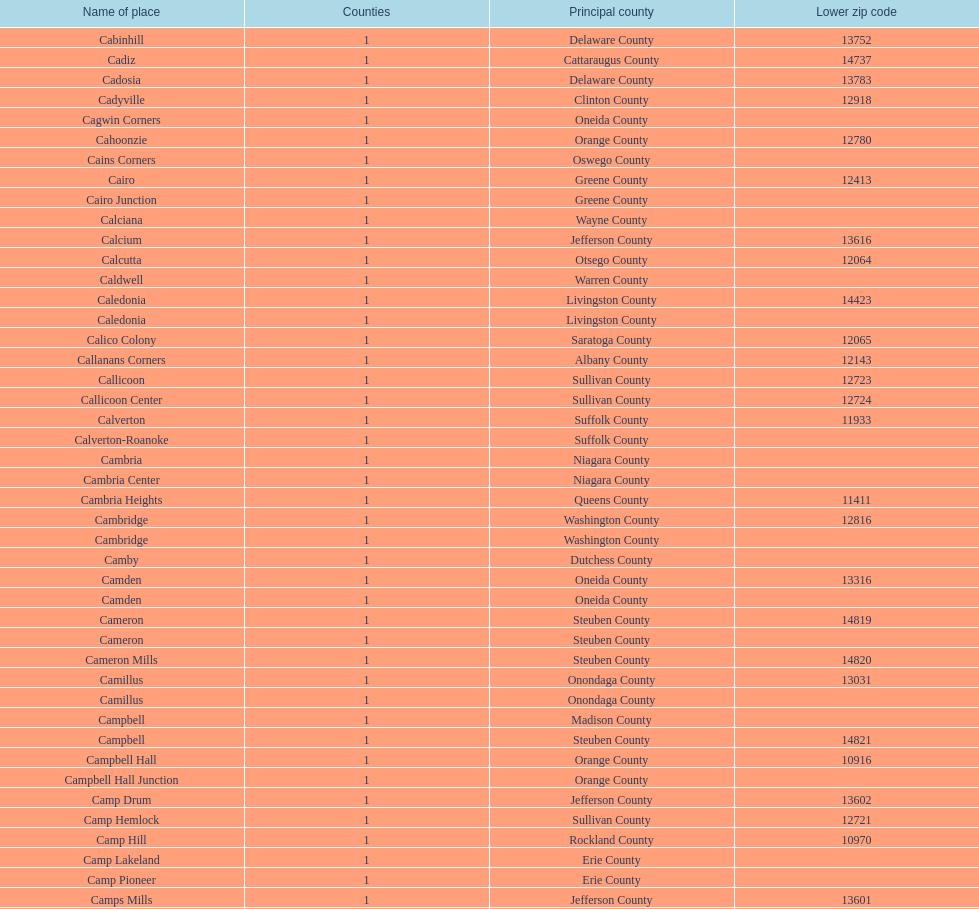Which place has the lowest, lower zip code? Cooper. 